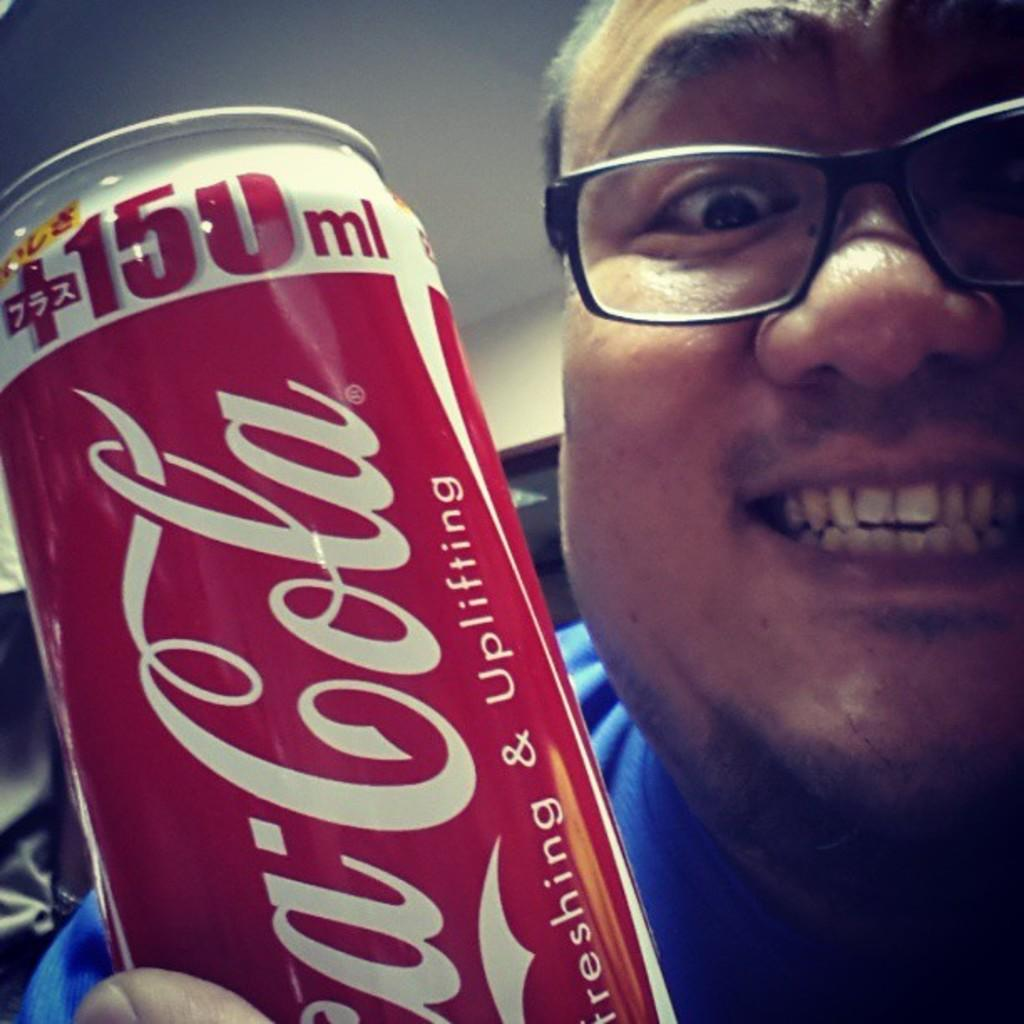<image>
Provide a brief description of the given image. A man holds a Coca Cola can up and smiles. 